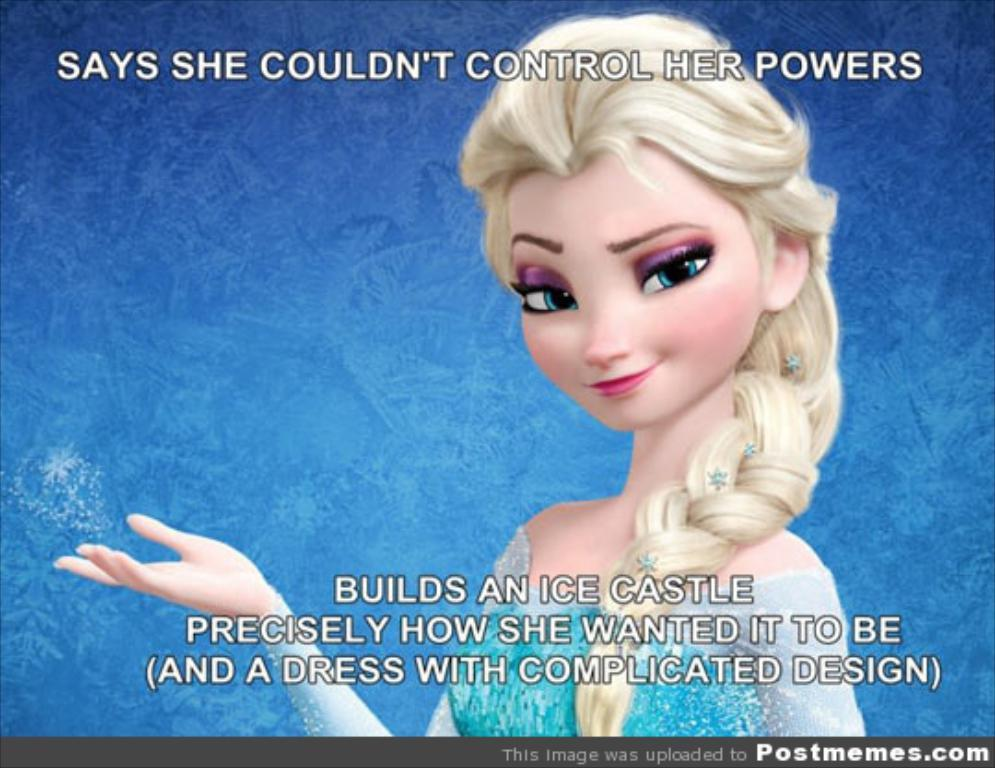What is the main object in the image? There is a banner in the image. What is depicted on the banner? The banner features a woman. What is the woman wearing? The woman is wearing a sky blue color dress. What else can be seen on the banner besides the woman? There is some matter or text on the banner. Can you see the woman on the banner performing any action? There is no action being performed by the woman on the banner; she is simply depicted as a static image. 